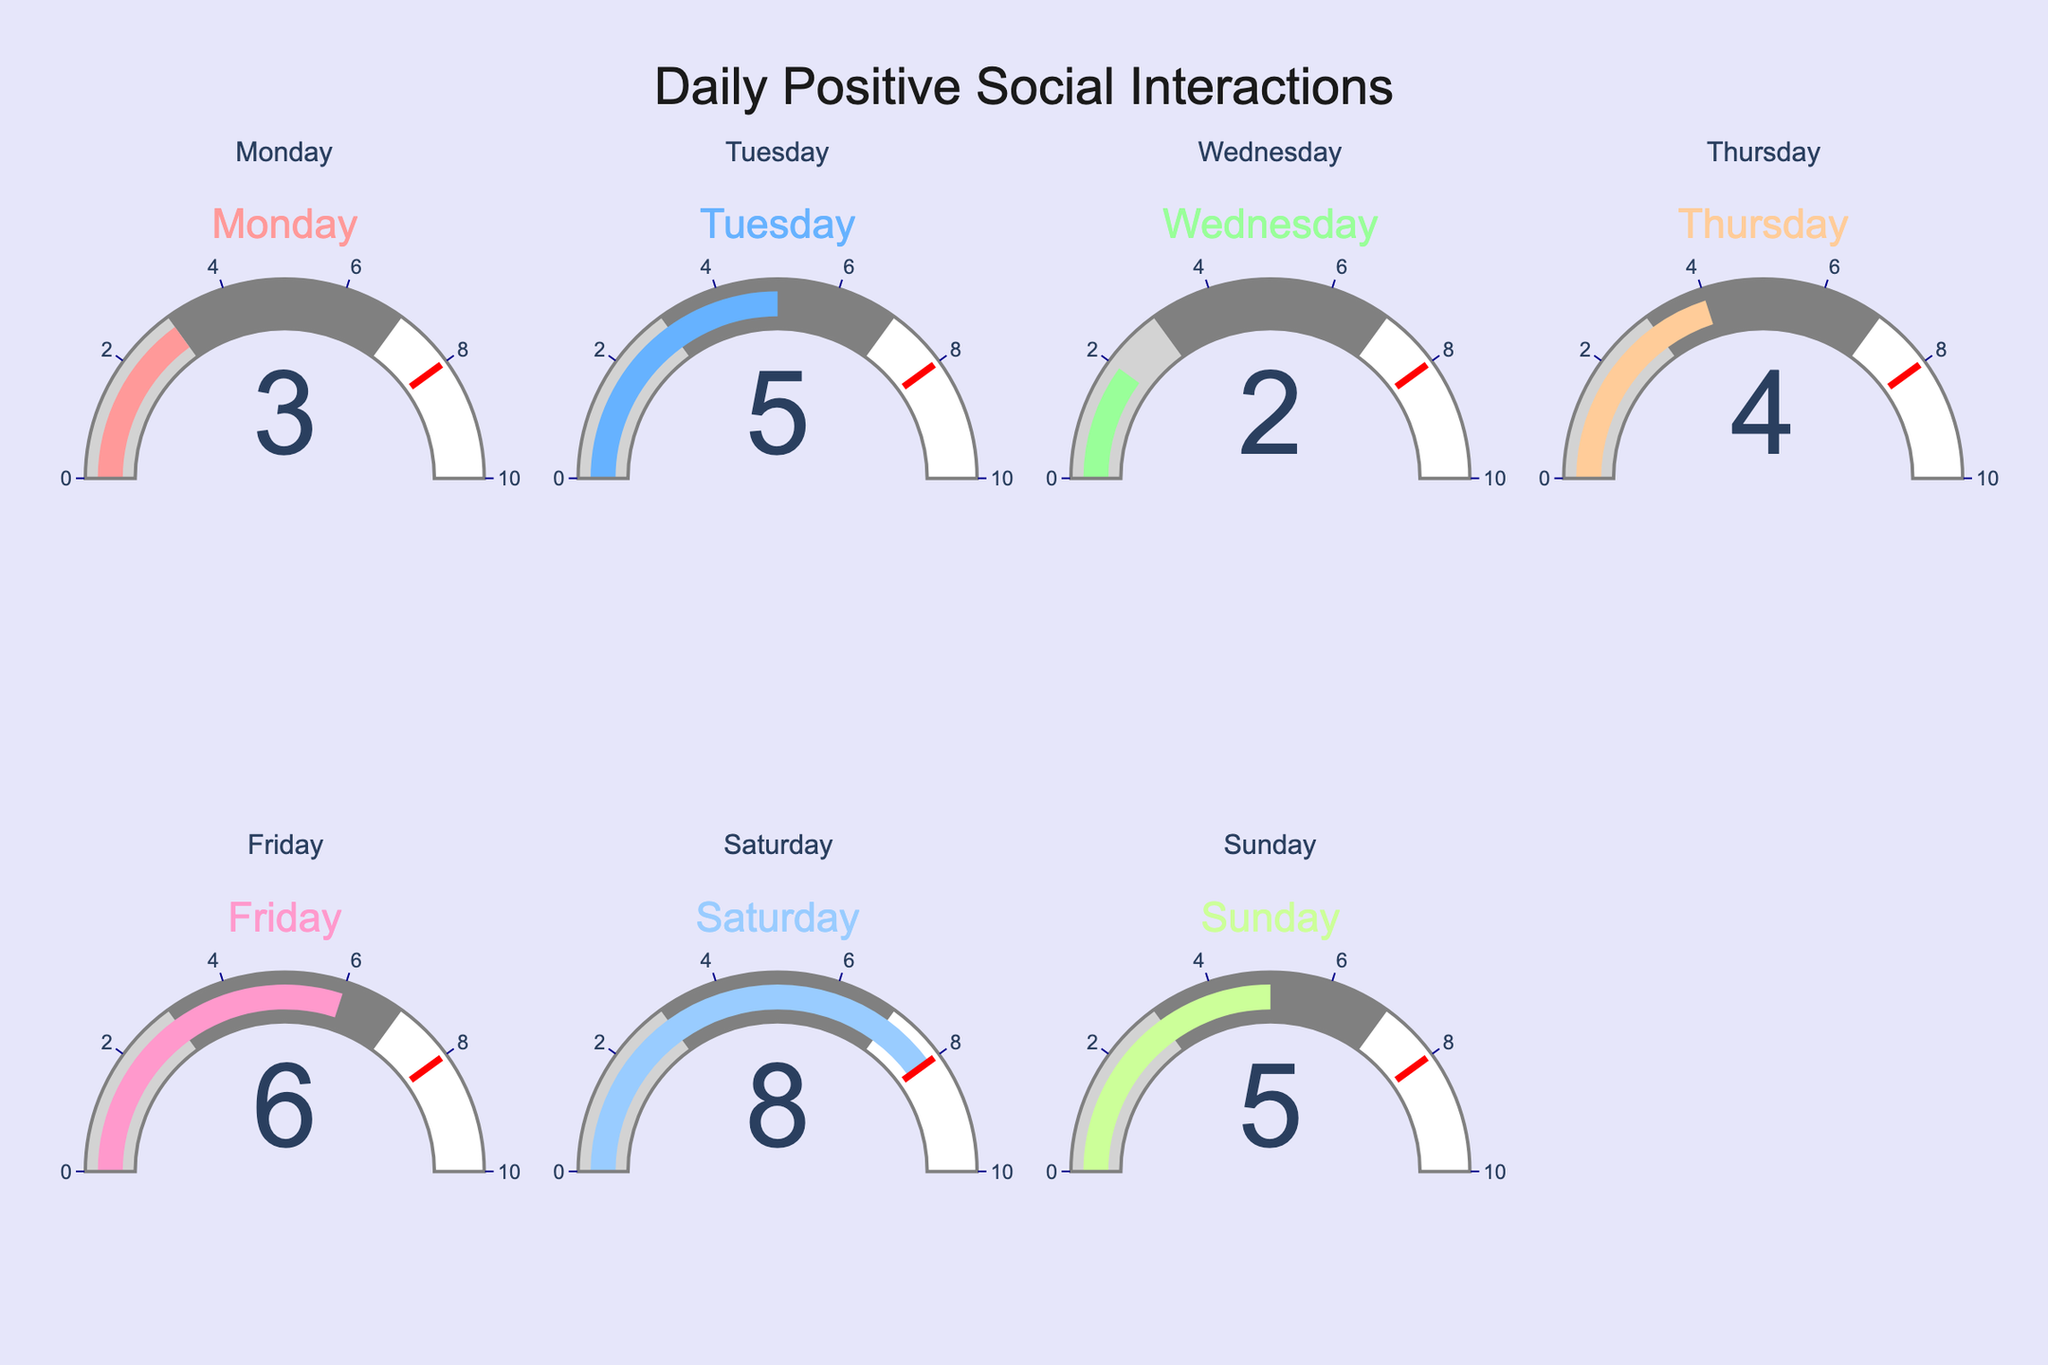what's the highest number of positive social interactions in a day? Scan through the gauge charts to identify the day with the highest value. Saturday has the highest value of 8 interactions.
Answer: 8 which day had the least number of interactions? Look for the gauge with the lowest value. Wednesday has the lowest number of interactions with 2.
Answer: Wednesday how many total positive social interactions were there over the week? Sum the values from all the gauges: 3 + 5 + 2 + 4 + 6 + 8 + 5 = 33
Answer: 33 what's the average number of interactions per day? Calculate the average by dividing the total interactions by the number of days: 33 / 7 ≈ 4.71
Answer: 4.71 did Friday have more interactions than Monday? Compare the values shown on the gauges for Friday and Monday. Friday has 6 interactions, whereas Monday has 3. Yes, Friday had more interactions.
Answer: Yes what's the difference in interactions between the day with the most and the least interactions? Subtract the lowest value (Wednesday, 2) from the highest value (Saturday, 8): 8 - 2 = 6
Answer: 6 how many days had interactions greater than 3? Count the gauges with values greater than 3: Tuesday (5), Thursday (4), Friday (6), Saturday (8), Sunday (5): 5 days
Answer: 5 which days had exactly 5 interactions? Identify the gauges with the value 5. Both Tuesday and Sunday have exactly 5 interactions.
Answer: Tuesday and Sunday 